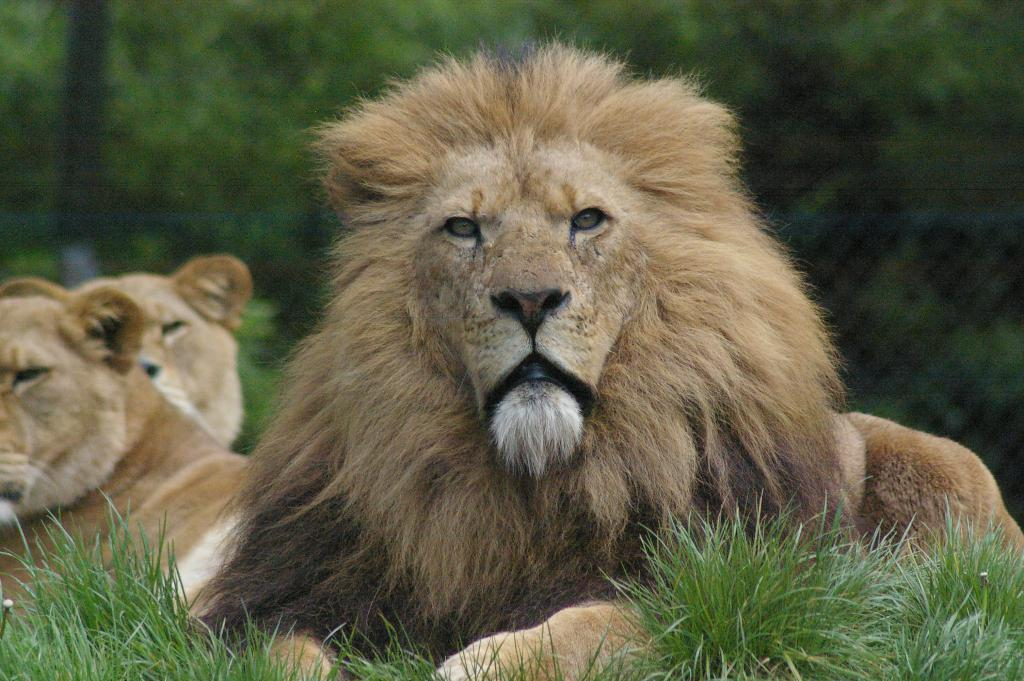What animals can be seen in the image? There is a lion and a lioness in the image. What are the positions of the lion and lioness in the image? Both the lion and lioness are sitting on the ground. What type of vegetation is visible at the bottom of the image? There is green grass at the bottom of the image. What can be seen in the background of the image? There are trees in the background of the image. What type of popcorn is being weighed on the scale in the image? There is no popcorn or scale present in the image; it features a lion and lioness sitting on the ground with green grass and trees in the background. 